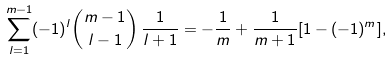Convert formula to latex. <formula><loc_0><loc_0><loc_500><loc_500>\sum _ { l = 1 } ^ { m - 1 } ( - 1 ) ^ { l } { m - 1 \choose { l - 1 } } \, \frac { 1 } { l + 1 } = - \frac { 1 } { m } + \frac { 1 } { m + 1 } [ 1 - ( - 1 ) ^ { m } ] ,</formula> 